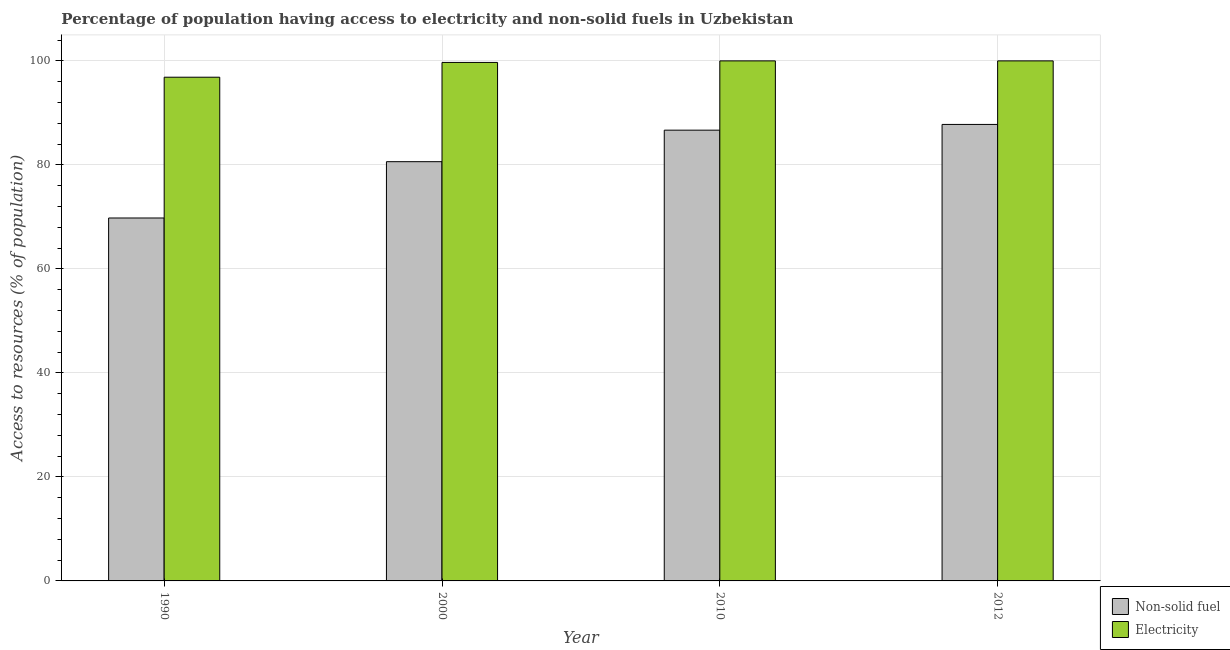In how many cases, is the number of bars for a given year not equal to the number of legend labels?
Make the answer very short. 0. What is the percentage of population having access to non-solid fuel in 2010?
Keep it short and to the point. 86.68. Across all years, what is the maximum percentage of population having access to electricity?
Your response must be concise. 100. Across all years, what is the minimum percentage of population having access to electricity?
Offer a very short reply. 96.86. In which year was the percentage of population having access to non-solid fuel maximum?
Your response must be concise. 2012. In which year was the percentage of population having access to electricity minimum?
Ensure brevity in your answer.  1990. What is the total percentage of population having access to electricity in the graph?
Your response must be concise. 396.56. What is the difference between the percentage of population having access to non-solid fuel in 2000 and that in 2010?
Give a very brief answer. -6.06. What is the difference between the percentage of population having access to electricity in 1990 and the percentage of population having access to non-solid fuel in 2000?
Your answer should be very brief. -2.84. What is the average percentage of population having access to non-solid fuel per year?
Provide a short and direct response. 81.22. In the year 2000, what is the difference between the percentage of population having access to non-solid fuel and percentage of population having access to electricity?
Make the answer very short. 0. What is the ratio of the percentage of population having access to electricity in 1990 to that in 2000?
Provide a succinct answer. 0.97. Is the percentage of population having access to electricity in 2000 less than that in 2010?
Offer a very short reply. Yes. Is the difference between the percentage of population having access to electricity in 2010 and 2012 greater than the difference between the percentage of population having access to non-solid fuel in 2010 and 2012?
Provide a succinct answer. No. What is the difference between the highest and the second highest percentage of population having access to electricity?
Give a very brief answer. 0. What is the difference between the highest and the lowest percentage of population having access to electricity?
Ensure brevity in your answer.  3.14. Is the sum of the percentage of population having access to non-solid fuel in 2010 and 2012 greater than the maximum percentage of population having access to electricity across all years?
Your answer should be very brief. Yes. What does the 2nd bar from the left in 2010 represents?
Ensure brevity in your answer.  Electricity. What does the 2nd bar from the right in 2012 represents?
Ensure brevity in your answer.  Non-solid fuel. Does the graph contain any zero values?
Provide a short and direct response. No. Does the graph contain grids?
Keep it short and to the point. Yes. Where does the legend appear in the graph?
Ensure brevity in your answer.  Bottom right. How many legend labels are there?
Your answer should be very brief. 2. How are the legend labels stacked?
Ensure brevity in your answer.  Vertical. What is the title of the graph?
Your response must be concise. Percentage of population having access to electricity and non-solid fuels in Uzbekistan. Does "By country of asylum" appear as one of the legend labels in the graph?
Offer a very short reply. No. What is the label or title of the X-axis?
Your answer should be very brief. Year. What is the label or title of the Y-axis?
Keep it short and to the point. Access to resources (% of population). What is the Access to resources (% of population) in Non-solid fuel in 1990?
Make the answer very short. 69.79. What is the Access to resources (% of population) in Electricity in 1990?
Offer a terse response. 96.86. What is the Access to resources (% of population) of Non-solid fuel in 2000?
Make the answer very short. 80.62. What is the Access to resources (% of population) of Electricity in 2000?
Your answer should be compact. 99.7. What is the Access to resources (% of population) of Non-solid fuel in 2010?
Your answer should be compact. 86.68. What is the Access to resources (% of population) in Electricity in 2010?
Your answer should be very brief. 100. What is the Access to resources (% of population) in Non-solid fuel in 2012?
Keep it short and to the point. 87.78. What is the Access to resources (% of population) of Electricity in 2012?
Provide a short and direct response. 100. Across all years, what is the maximum Access to resources (% of population) in Non-solid fuel?
Ensure brevity in your answer.  87.78. Across all years, what is the maximum Access to resources (% of population) in Electricity?
Ensure brevity in your answer.  100. Across all years, what is the minimum Access to resources (% of population) of Non-solid fuel?
Your answer should be very brief. 69.79. Across all years, what is the minimum Access to resources (% of population) of Electricity?
Offer a very short reply. 96.86. What is the total Access to resources (% of population) in Non-solid fuel in the graph?
Make the answer very short. 324.86. What is the total Access to resources (% of population) in Electricity in the graph?
Your answer should be compact. 396.56. What is the difference between the Access to resources (% of population) in Non-solid fuel in 1990 and that in 2000?
Offer a very short reply. -10.83. What is the difference between the Access to resources (% of population) of Electricity in 1990 and that in 2000?
Give a very brief answer. -2.84. What is the difference between the Access to resources (% of population) of Non-solid fuel in 1990 and that in 2010?
Make the answer very short. -16.89. What is the difference between the Access to resources (% of population) of Electricity in 1990 and that in 2010?
Provide a succinct answer. -3.14. What is the difference between the Access to resources (% of population) in Non-solid fuel in 1990 and that in 2012?
Give a very brief answer. -17.99. What is the difference between the Access to resources (% of population) in Electricity in 1990 and that in 2012?
Offer a terse response. -3.14. What is the difference between the Access to resources (% of population) in Non-solid fuel in 2000 and that in 2010?
Keep it short and to the point. -6.06. What is the difference between the Access to resources (% of population) of Electricity in 2000 and that in 2010?
Make the answer very short. -0.3. What is the difference between the Access to resources (% of population) of Non-solid fuel in 2000 and that in 2012?
Offer a terse response. -7.16. What is the difference between the Access to resources (% of population) of Electricity in 2000 and that in 2012?
Offer a very short reply. -0.3. What is the difference between the Access to resources (% of population) in Non-solid fuel in 2010 and that in 2012?
Ensure brevity in your answer.  -1.1. What is the difference between the Access to resources (% of population) of Electricity in 2010 and that in 2012?
Offer a very short reply. 0. What is the difference between the Access to resources (% of population) of Non-solid fuel in 1990 and the Access to resources (% of population) of Electricity in 2000?
Provide a short and direct response. -29.91. What is the difference between the Access to resources (% of population) of Non-solid fuel in 1990 and the Access to resources (% of population) of Electricity in 2010?
Make the answer very short. -30.21. What is the difference between the Access to resources (% of population) in Non-solid fuel in 1990 and the Access to resources (% of population) in Electricity in 2012?
Your answer should be very brief. -30.21. What is the difference between the Access to resources (% of population) in Non-solid fuel in 2000 and the Access to resources (% of population) in Electricity in 2010?
Make the answer very short. -19.38. What is the difference between the Access to resources (% of population) in Non-solid fuel in 2000 and the Access to resources (% of population) in Electricity in 2012?
Provide a short and direct response. -19.38. What is the difference between the Access to resources (% of population) of Non-solid fuel in 2010 and the Access to resources (% of population) of Electricity in 2012?
Give a very brief answer. -13.32. What is the average Access to resources (% of population) of Non-solid fuel per year?
Your answer should be very brief. 81.22. What is the average Access to resources (% of population) in Electricity per year?
Give a very brief answer. 99.14. In the year 1990, what is the difference between the Access to resources (% of population) of Non-solid fuel and Access to resources (% of population) of Electricity?
Give a very brief answer. -27.07. In the year 2000, what is the difference between the Access to resources (% of population) in Non-solid fuel and Access to resources (% of population) in Electricity?
Offer a very short reply. -19.08. In the year 2010, what is the difference between the Access to resources (% of population) of Non-solid fuel and Access to resources (% of population) of Electricity?
Offer a very short reply. -13.32. In the year 2012, what is the difference between the Access to resources (% of population) in Non-solid fuel and Access to resources (% of population) in Electricity?
Make the answer very short. -12.22. What is the ratio of the Access to resources (% of population) of Non-solid fuel in 1990 to that in 2000?
Your answer should be compact. 0.87. What is the ratio of the Access to resources (% of population) of Electricity in 1990 to that in 2000?
Your answer should be very brief. 0.97. What is the ratio of the Access to resources (% of population) of Non-solid fuel in 1990 to that in 2010?
Your answer should be very brief. 0.81. What is the ratio of the Access to resources (% of population) in Electricity in 1990 to that in 2010?
Your response must be concise. 0.97. What is the ratio of the Access to resources (% of population) of Non-solid fuel in 1990 to that in 2012?
Your response must be concise. 0.8. What is the ratio of the Access to resources (% of population) in Electricity in 1990 to that in 2012?
Offer a very short reply. 0.97. What is the ratio of the Access to resources (% of population) of Non-solid fuel in 2000 to that in 2010?
Keep it short and to the point. 0.93. What is the ratio of the Access to resources (% of population) of Non-solid fuel in 2000 to that in 2012?
Give a very brief answer. 0.92. What is the ratio of the Access to resources (% of population) of Non-solid fuel in 2010 to that in 2012?
Your answer should be compact. 0.99. What is the ratio of the Access to resources (% of population) in Electricity in 2010 to that in 2012?
Give a very brief answer. 1. What is the difference between the highest and the second highest Access to resources (% of population) in Non-solid fuel?
Offer a terse response. 1.1. What is the difference between the highest and the lowest Access to resources (% of population) in Non-solid fuel?
Keep it short and to the point. 17.99. What is the difference between the highest and the lowest Access to resources (% of population) of Electricity?
Ensure brevity in your answer.  3.14. 